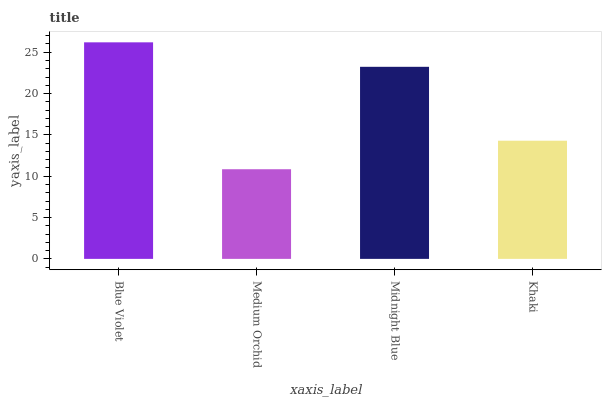Is Medium Orchid the minimum?
Answer yes or no. Yes. Is Blue Violet the maximum?
Answer yes or no. Yes. Is Midnight Blue the minimum?
Answer yes or no. No. Is Midnight Blue the maximum?
Answer yes or no. No. Is Midnight Blue greater than Medium Orchid?
Answer yes or no. Yes. Is Medium Orchid less than Midnight Blue?
Answer yes or no. Yes. Is Medium Orchid greater than Midnight Blue?
Answer yes or no. No. Is Midnight Blue less than Medium Orchid?
Answer yes or no. No. Is Midnight Blue the high median?
Answer yes or no. Yes. Is Khaki the low median?
Answer yes or no. Yes. Is Khaki the high median?
Answer yes or no. No. Is Blue Violet the low median?
Answer yes or no. No. 